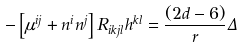<formula> <loc_0><loc_0><loc_500><loc_500>- \left [ \mu ^ { i j } + n ^ { i } n ^ { j } \right ] R _ { i k j l } h ^ { k l } = \frac { ( 2 d - 6 ) } { r } \Delta</formula> 